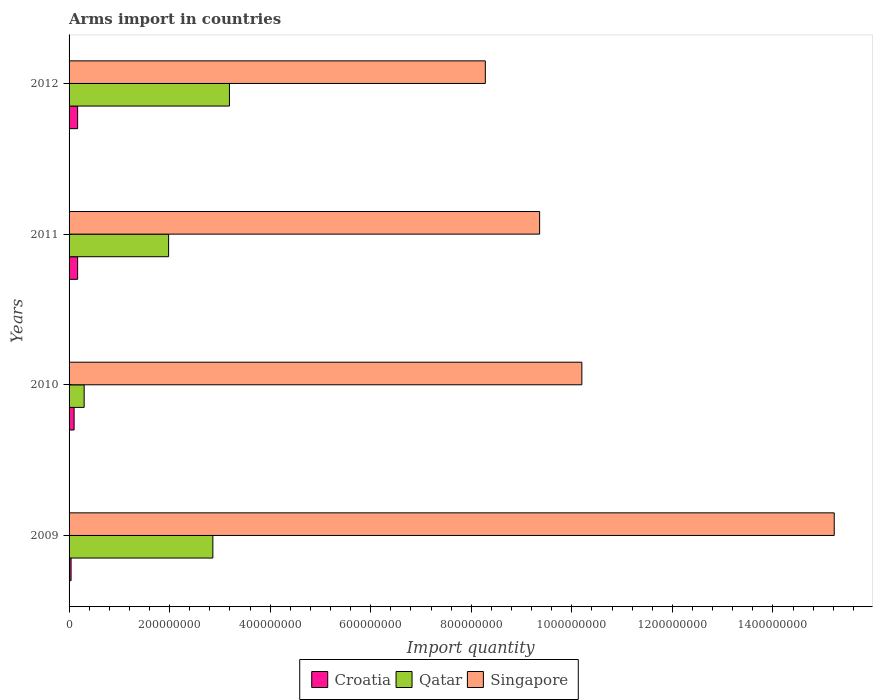How many different coloured bars are there?
Offer a terse response. 3. How many bars are there on the 3rd tick from the top?
Give a very brief answer. 3. What is the label of the 1st group of bars from the top?
Your answer should be very brief. 2012. In how many cases, is the number of bars for a given year not equal to the number of legend labels?
Offer a terse response. 0. What is the total arms import in Qatar in 2011?
Your answer should be compact. 1.98e+08. Across all years, what is the maximum total arms import in Croatia?
Give a very brief answer. 1.70e+07. Across all years, what is the minimum total arms import in Singapore?
Your response must be concise. 8.28e+08. What is the total total arms import in Croatia in the graph?
Ensure brevity in your answer.  4.80e+07. What is the difference between the total arms import in Croatia in 2009 and that in 2011?
Offer a terse response. -1.30e+07. What is the difference between the total arms import in Qatar in 2010 and the total arms import in Croatia in 2009?
Offer a terse response. 2.60e+07. What is the average total arms import in Singapore per year?
Provide a succinct answer. 1.08e+09. In the year 2010, what is the difference between the total arms import in Croatia and total arms import in Singapore?
Your answer should be very brief. -1.01e+09. What is the ratio of the total arms import in Singapore in 2009 to that in 2011?
Offer a terse response. 1.63. What is the difference between the highest and the second highest total arms import in Qatar?
Offer a terse response. 3.30e+07. What is the difference between the highest and the lowest total arms import in Singapore?
Provide a succinct answer. 6.94e+08. In how many years, is the total arms import in Qatar greater than the average total arms import in Qatar taken over all years?
Ensure brevity in your answer.  2. What does the 2nd bar from the top in 2011 represents?
Keep it short and to the point. Qatar. What does the 2nd bar from the bottom in 2012 represents?
Give a very brief answer. Qatar. Are all the bars in the graph horizontal?
Your response must be concise. Yes. How are the legend labels stacked?
Provide a succinct answer. Horizontal. What is the title of the graph?
Offer a very short reply. Arms import in countries. What is the label or title of the X-axis?
Make the answer very short. Import quantity. What is the label or title of the Y-axis?
Your answer should be compact. Years. What is the Import quantity in Croatia in 2009?
Make the answer very short. 4.00e+06. What is the Import quantity in Qatar in 2009?
Provide a succinct answer. 2.86e+08. What is the Import quantity in Singapore in 2009?
Your answer should be compact. 1.52e+09. What is the Import quantity of Qatar in 2010?
Keep it short and to the point. 3.00e+07. What is the Import quantity of Singapore in 2010?
Your answer should be very brief. 1.02e+09. What is the Import quantity in Croatia in 2011?
Your answer should be very brief. 1.70e+07. What is the Import quantity of Qatar in 2011?
Ensure brevity in your answer.  1.98e+08. What is the Import quantity of Singapore in 2011?
Give a very brief answer. 9.36e+08. What is the Import quantity of Croatia in 2012?
Your response must be concise. 1.70e+07. What is the Import quantity in Qatar in 2012?
Offer a terse response. 3.19e+08. What is the Import quantity in Singapore in 2012?
Make the answer very short. 8.28e+08. Across all years, what is the maximum Import quantity in Croatia?
Offer a very short reply. 1.70e+07. Across all years, what is the maximum Import quantity in Qatar?
Give a very brief answer. 3.19e+08. Across all years, what is the maximum Import quantity of Singapore?
Make the answer very short. 1.52e+09. Across all years, what is the minimum Import quantity in Qatar?
Keep it short and to the point. 3.00e+07. Across all years, what is the minimum Import quantity of Singapore?
Your answer should be very brief. 8.28e+08. What is the total Import quantity of Croatia in the graph?
Provide a succinct answer. 4.80e+07. What is the total Import quantity in Qatar in the graph?
Offer a terse response. 8.33e+08. What is the total Import quantity of Singapore in the graph?
Provide a short and direct response. 4.31e+09. What is the difference between the Import quantity in Croatia in 2009 and that in 2010?
Provide a short and direct response. -6.00e+06. What is the difference between the Import quantity of Qatar in 2009 and that in 2010?
Give a very brief answer. 2.56e+08. What is the difference between the Import quantity of Singapore in 2009 and that in 2010?
Give a very brief answer. 5.02e+08. What is the difference between the Import quantity in Croatia in 2009 and that in 2011?
Offer a very short reply. -1.30e+07. What is the difference between the Import quantity of Qatar in 2009 and that in 2011?
Your response must be concise. 8.80e+07. What is the difference between the Import quantity of Singapore in 2009 and that in 2011?
Keep it short and to the point. 5.86e+08. What is the difference between the Import quantity in Croatia in 2009 and that in 2012?
Provide a short and direct response. -1.30e+07. What is the difference between the Import quantity of Qatar in 2009 and that in 2012?
Ensure brevity in your answer.  -3.30e+07. What is the difference between the Import quantity in Singapore in 2009 and that in 2012?
Offer a very short reply. 6.94e+08. What is the difference between the Import quantity of Croatia in 2010 and that in 2011?
Offer a very short reply. -7.00e+06. What is the difference between the Import quantity of Qatar in 2010 and that in 2011?
Your response must be concise. -1.68e+08. What is the difference between the Import quantity in Singapore in 2010 and that in 2011?
Offer a very short reply. 8.40e+07. What is the difference between the Import quantity of Croatia in 2010 and that in 2012?
Provide a succinct answer. -7.00e+06. What is the difference between the Import quantity of Qatar in 2010 and that in 2012?
Your response must be concise. -2.89e+08. What is the difference between the Import quantity in Singapore in 2010 and that in 2012?
Ensure brevity in your answer.  1.92e+08. What is the difference between the Import quantity of Qatar in 2011 and that in 2012?
Provide a short and direct response. -1.21e+08. What is the difference between the Import quantity of Singapore in 2011 and that in 2012?
Offer a very short reply. 1.08e+08. What is the difference between the Import quantity in Croatia in 2009 and the Import quantity in Qatar in 2010?
Your response must be concise. -2.60e+07. What is the difference between the Import quantity of Croatia in 2009 and the Import quantity of Singapore in 2010?
Ensure brevity in your answer.  -1.02e+09. What is the difference between the Import quantity in Qatar in 2009 and the Import quantity in Singapore in 2010?
Offer a very short reply. -7.34e+08. What is the difference between the Import quantity in Croatia in 2009 and the Import quantity in Qatar in 2011?
Your answer should be compact. -1.94e+08. What is the difference between the Import quantity in Croatia in 2009 and the Import quantity in Singapore in 2011?
Your answer should be compact. -9.32e+08. What is the difference between the Import quantity in Qatar in 2009 and the Import quantity in Singapore in 2011?
Provide a succinct answer. -6.50e+08. What is the difference between the Import quantity in Croatia in 2009 and the Import quantity in Qatar in 2012?
Provide a succinct answer. -3.15e+08. What is the difference between the Import quantity in Croatia in 2009 and the Import quantity in Singapore in 2012?
Give a very brief answer. -8.24e+08. What is the difference between the Import quantity in Qatar in 2009 and the Import quantity in Singapore in 2012?
Provide a short and direct response. -5.42e+08. What is the difference between the Import quantity in Croatia in 2010 and the Import quantity in Qatar in 2011?
Give a very brief answer. -1.88e+08. What is the difference between the Import quantity in Croatia in 2010 and the Import quantity in Singapore in 2011?
Keep it short and to the point. -9.26e+08. What is the difference between the Import quantity in Qatar in 2010 and the Import quantity in Singapore in 2011?
Ensure brevity in your answer.  -9.06e+08. What is the difference between the Import quantity in Croatia in 2010 and the Import quantity in Qatar in 2012?
Provide a short and direct response. -3.09e+08. What is the difference between the Import quantity in Croatia in 2010 and the Import quantity in Singapore in 2012?
Make the answer very short. -8.18e+08. What is the difference between the Import quantity of Qatar in 2010 and the Import quantity of Singapore in 2012?
Make the answer very short. -7.98e+08. What is the difference between the Import quantity in Croatia in 2011 and the Import quantity in Qatar in 2012?
Provide a succinct answer. -3.02e+08. What is the difference between the Import quantity in Croatia in 2011 and the Import quantity in Singapore in 2012?
Your answer should be compact. -8.11e+08. What is the difference between the Import quantity of Qatar in 2011 and the Import quantity of Singapore in 2012?
Provide a succinct answer. -6.30e+08. What is the average Import quantity of Qatar per year?
Make the answer very short. 2.08e+08. What is the average Import quantity in Singapore per year?
Your response must be concise. 1.08e+09. In the year 2009, what is the difference between the Import quantity in Croatia and Import quantity in Qatar?
Provide a succinct answer. -2.82e+08. In the year 2009, what is the difference between the Import quantity in Croatia and Import quantity in Singapore?
Your response must be concise. -1.52e+09. In the year 2009, what is the difference between the Import quantity of Qatar and Import quantity of Singapore?
Provide a succinct answer. -1.24e+09. In the year 2010, what is the difference between the Import quantity of Croatia and Import quantity of Qatar?
Your answer should be very brief. -2.00e+07. In the year 2010, what is the difference between the Import quantity in Croatia and Import quantity in Singapore?
Offer a terse response. -1.01e+09. In the year 2010, what is the difference between the Import quantity in Qatar and Import quantity in Singapore?
Give a very brief answer. -9.90e+08. In the year 2011, what is the difference between the Import quantity of Croatia and Import quantity of Qatar?
Ensure brevity in your answer.  -1.81e+08. In the year 2011, what is the difference between the Import quantity in Croatia and Import quantity in Singapore?
Your answer should be compact. -9.19e+08. In the year 2011, what is the difference between the Import quantity in Qatar and Import quantity in Singapore?
Give a very brief answer. -7.38e+08. In the year 2012, what is the difference between the Import quantity in Croatia and Import quantity in Qatar?
Provide a succinct answer. -3.02e+08. In the year 2012, what is the difference between the Import quantity of Croatia and Import quantity of Singapore?
Give a very brief answer. -8.11e+08. In the year 2012, what is the difference between the Import quantity of Qatar and Import quantity of Singapore?
Your answer should be compact. -5.09e+08. What is the ratio of the Import quantity of Qatar in 2009 to that in 2010?
Keep it short and to the point. 9.53. What is the ratio of the Import quantity of Singapore in 2009 to that in 2010?
Provide a succinct answer. 1.49. What is the ratio of the Import quantity of Croatia in 2009 to that in 2011?
Offer a terse response. 0.24. What is the ratio of the Import quantity of Qatar in 2009 to that in 2011?
Provide a succinct answer. 1.44. What is the ratio of the Import quantity of Singapore in 2009 to that in 2011?
Your response must be concise. 1.63. What is the ratio of the Import quantity of Croatia in 2009 to that in 2012?
Offer a very short reply. 0.24. What is the ratio of the Import quantity of Qatar in 2009 to that in 2012?
Ensure brevity in your answer.  0.9. What is the ratio of the Import quantity of Singapore in 2009 to that in 2012?
Keep it short and to the point. 1.84. What is the ratio of the Import quantity in Croatia in 2010 to that in 2011?
Give a very brief answer. 0.59. What is the ratio of the Import quantity in Qatar in 2010 to that in 2011?
Offer a terse response. 0.15. What is the ratio of the Import quantity in Singapore in 2010 to that in 2011?
Offer a terse response. 1.09. What is the ratio of the Import quantity in Croatia in 2010 to that in 2012?
Ensure brevity in your answer.  0.59. What is the ratio of the Import quantity in Qatar in 2010 to that in 2012?
Your answer should be very brief. 0.09. What is the ratio of the Import quantity in Singapore in 2010 to that in 2012?
Your answer should be very brief. 1.23. What is the ratio of the Import quantity of Croatia in 2011 to that in 2012?
Offer a terse response. 1. What is the ratio of the Import quantity in Qatar in 2011 to that in 2012?
Your response must be concise. 0.62. What is the ratio of the Import quantity in Singapore in 2011 to that in 2012?
Ensure brevity in your answer.  1.13. What is the difference between the highest and the second highest Import quantity in Qatar?
Give a very brief answer. 3.30e+07. What is the difference between the highest and the second highest Import quantity in Singapore?
Offer a very short reply. 5.02e+08. What is the difference between the highest and the lowest Import quantity of Croatia?
Your response must be concise. 1.30e+07. What is the difference between the highest and the lowest Import quantity of Qatar?
Your answer should be compact. 2.89e+08. What is the difference between the highest and the lowest Import quantity in Singapore?
Offer a very short reply. 6.94e+08. 